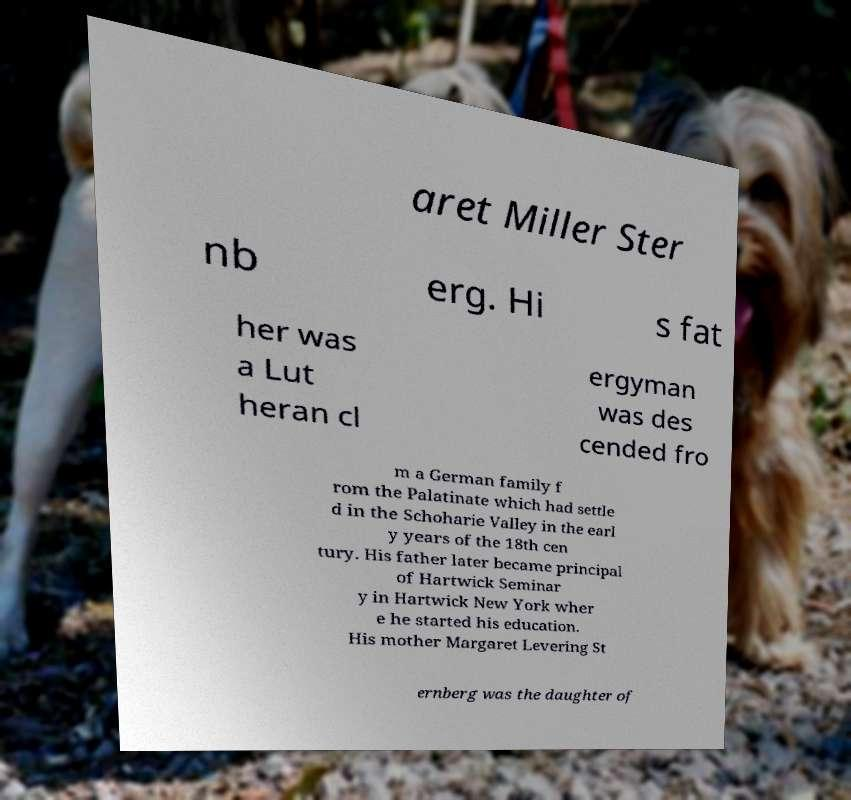Please identify and transcribe the text found in this image. aret Miller Ster nb erg. Hi s fat her was a Lut heran cl ergyman was des cended fro m a German family f rom the Palatinate which had settle d in the Schoharie Valley in the earl y years of the 18th cen tury. His father later became principal of Hartwick Seminar y in Hartwick New York wher e he started his education. His mother Margaret Levering St ernberg was the daughter of 